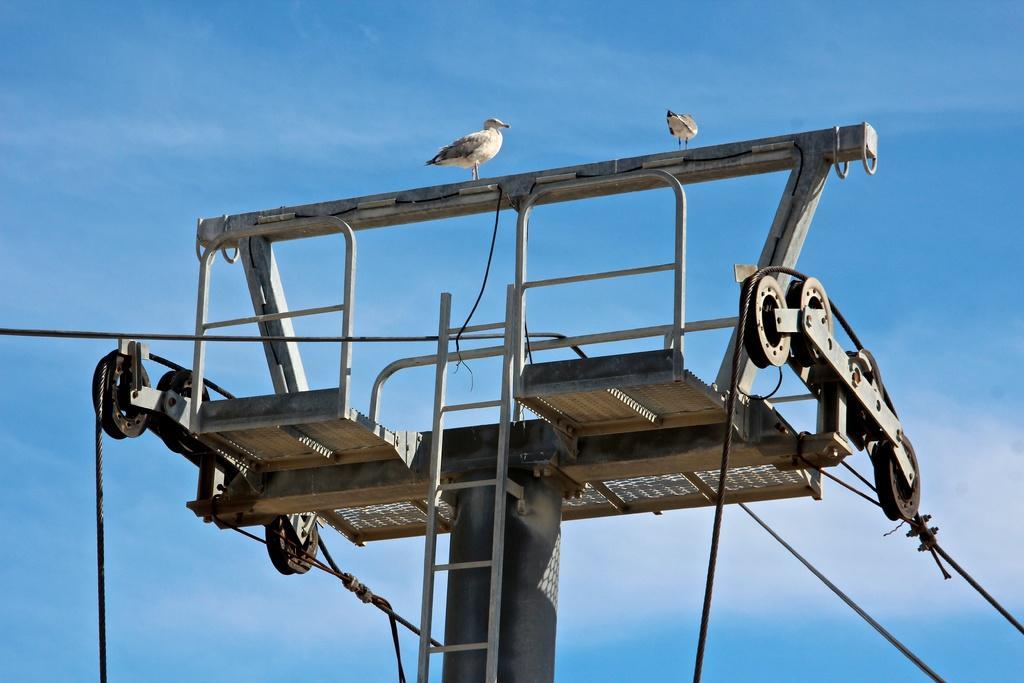Could you give a brief overview of what you see in this image? In this image, we can see a pole, there are some cables passing from the pole, there are two birds sitting on the pole, in the background there is a blue color sky. 